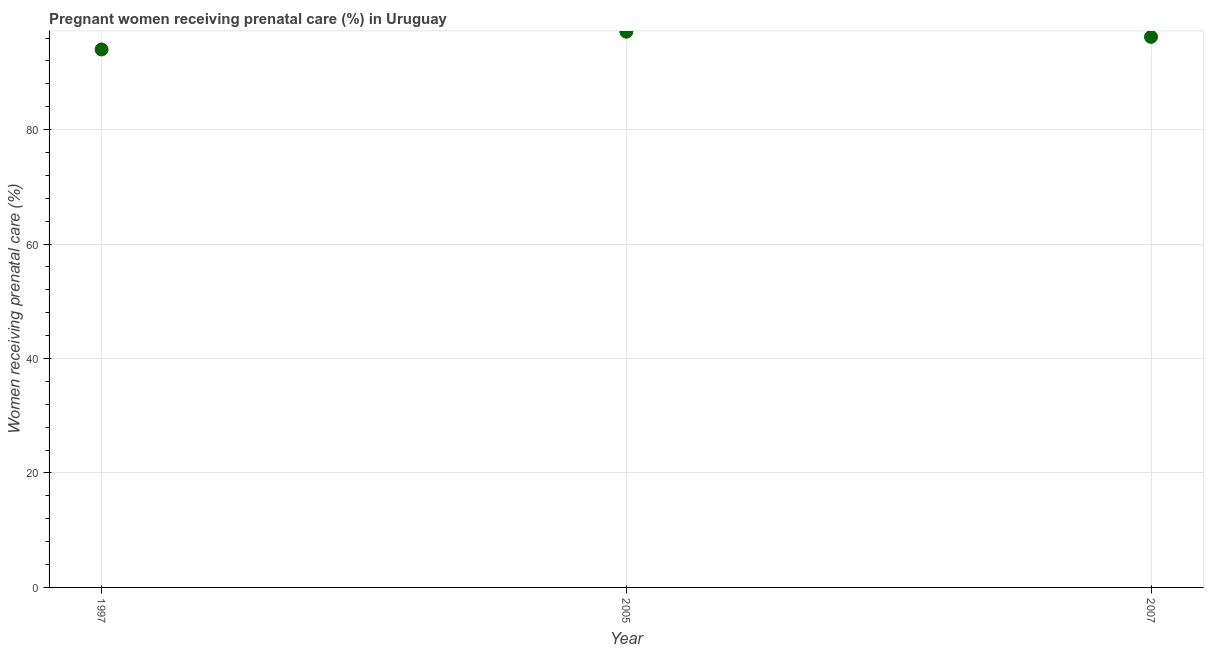What is the percentage of pregnant women receiving prenatal care in 2005?
Offer a very short reply. 97.1. Across all years, what is the maximum percentage of pregnant women receiving prenatal care?
Offer a terse response. 97.1. Across all years, what is the minimum percentage of pregnant women receiving prenatal care?
Your answer should be very brief. 94. In which year was the percentage of pregnant women receiving prenatal care minimum?
Your answer should be very brief. 1997. What is the sum of the percentage of pregnant women receiving prenatal care?
Your answer should be compact. 287.3. What is the difference between the percentage of pregnant women receiving prenatal care in 1997 and 2005?
Give a very brief answer. -3.1. What is the average percentage of pregnant women receiving prenatal care per year?
Make the answer very short. 95.77. What is the median percentage of pregnant women receiving prenatal care?
Give a very brief answer. 96.2. In how many years, is the percentage of pregnant women receiving prenatal care greater than 12 %?
Give a very brief answer. 3. What is the ratio of the percentage of pregnant women receiving prenatal care in 1997 to that in 2007?
Ensure brevity in your answer.  0.98. Is the difference between the percentage of pregnant women receiving prenatal care in 2005 and 2007 greater than the difference between any two years?
Offer a terse response. No. What is the difference between the highest and the second highest percentage of pregnant women receiving prenatal care?
Offer a very short reply. 0.9. Is the sum of the percentage of pregnant women receiving prenatal care in 1997 and 2005 greater than the maximum percentage of pregnant women receiving prenatal care across all years?
Provide a short and direct response. Yes. What is the difference between the highest and the lowest percentage of pregnant women receiving prenatal care?
Ensure brevity in your answer.  3.1. Does the percentage of pregnant women receiving prenatal care monotonically increase over the years?
Offer a very short reply. No. How many years are there in the graph?
Make the answer very short. 3. What is the difference between two consecutive major ticks on the Y-axis?
Make the answer very short. 20. Does the graph contain any zero values?
Offer a terse response. No. What is the title of the graph?
Your answer should be very brief. Pregnant women receiving prenatal care (%) in Uruguay. What is the label or title of the X-axis?
Keep it short and to the point. Year. What is the label or title of the Y-axis?
Provide a short and direct response. Women receiving prenatal care (%). What is the Women receiving prenatal care (%) in 1997?
Your response must be concise. 94. What is the Women receiving prenatal care (%) in 2005?
Offer a terse response. 97.1. What is the Women receiving prenatal care (%) in 2007?
Ensure brevity in your answer.  96.2. What is the difference between the Women receiving prenatal care (%) in 2005 and 2007?
Your answer should be compact. 0.9. What is the ratio of the Women receiving prenatal care (%) in 1997 to that in 2007?
Keep it short and to the point. 0.98. What is the ratio of the Women receiving prenatal care (%) in 2005 to that in 2007?
Keep it short and to the point. 1.01. 